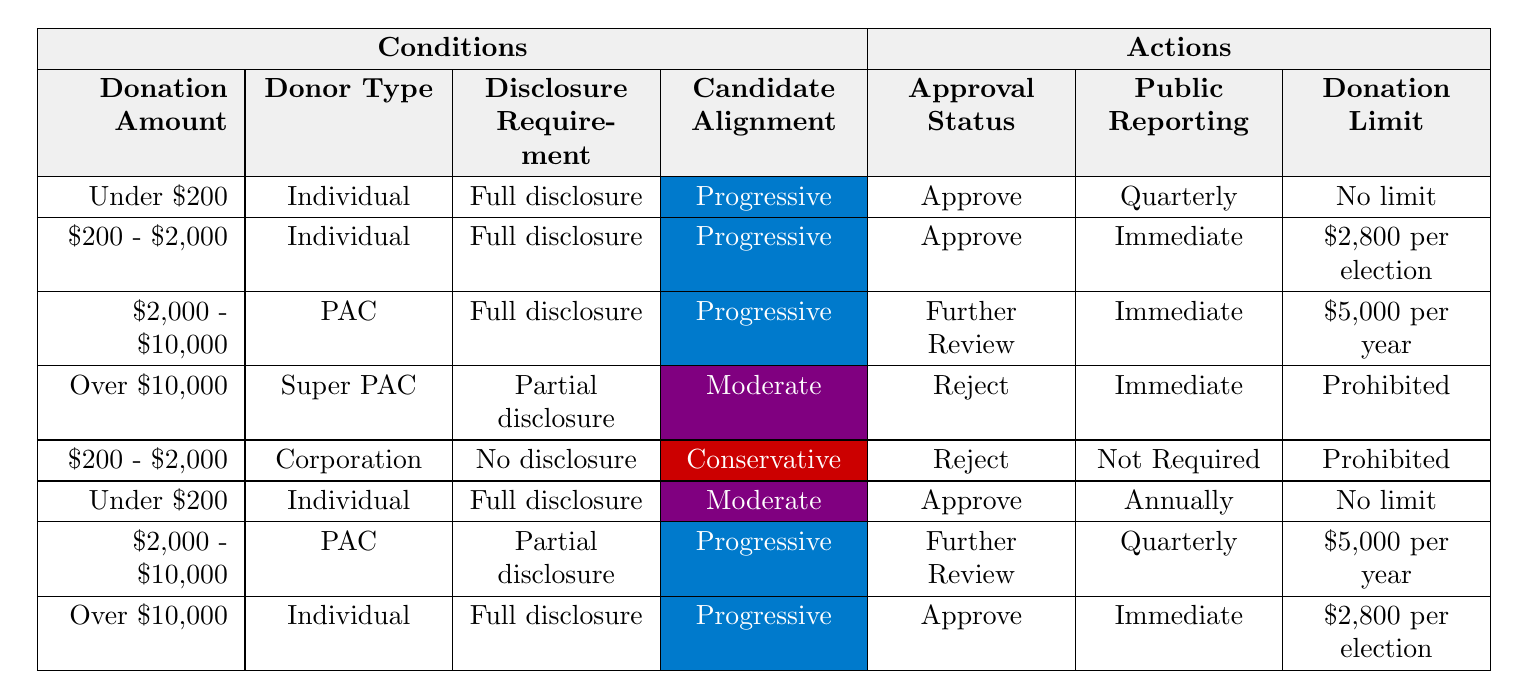What is the approval status for donations under $200 from individual donors who are progressive? According to the table, the conditions for "Under $200" from "Individual" donors with "Full disclosure" and "Progressive" alignment result in an "Approval Status" of "Approve."
Answer: Approve Do corporations face donation limits when the amount is between $200 and $2,000 with no disclosure and conservative alignment? The table indicates that "Corporation" donations in the "$200 - $2,000" range with "No disclosure" and "Conservative" alignment have a "Donation Limit" of "Prohibited."
Answer: Yes What is the public reporting frequency for PAC donations between $2,000 and $10,000 with full disclosure and progressive alignment? The table states that for donations from "PAC" within the "$2,000 - $10,000" range and "Full disclosure" with "Progressive" alignment, the public reporting is set to "Immediate."
Answer: Immediate How many different approval statuses are present for individual contributions? In the table, there are three unique "Approval Status" entries for individual contributions: "Approve" occurs for donations less than $200 and over $10,000, while "Further Review" and "Reject" also appear for specific amounts. Counting the unique statuses gives us three.
Answer: Three If a super PAC makes a contribution over $10,000 with partial disclosure, what will be the public reporting frequency? The table shows that for "Super PAC" contributions over "$10,000" with "Partial disclosure" and "Moderate" alignment, the public reporting frequency is "Immediate."
Answer: Immediate Is the donation limit for individual contributions over $10,000 with full disclosure and progressive alignment set to $2,800 per election? The table indicates that for individual contributions over "$10,000" with "Full disclosure" and "Progressive" alignment, the donation limit is "$2,800 per election." This indicates the statement is true.
Answer: No What is the donation limit for PAC contributions between $2,000 and $10,000 with partial disclosure and progressive alignment? According to the table, if a PAC makes a contribution in the range of "$2,000 - $10,000" with "Partial disclosure" and "Progressive" alignment, the specified "Donation Limit" is "$5,000 per year."
Answer: $5,000 per year Are there any conditions under which a corporation can have no limit on donations? By examining the table, there are no conditions listed where a corporation can have "No limit" on donations; all examples show limits or prohibitions.
Answer: No 